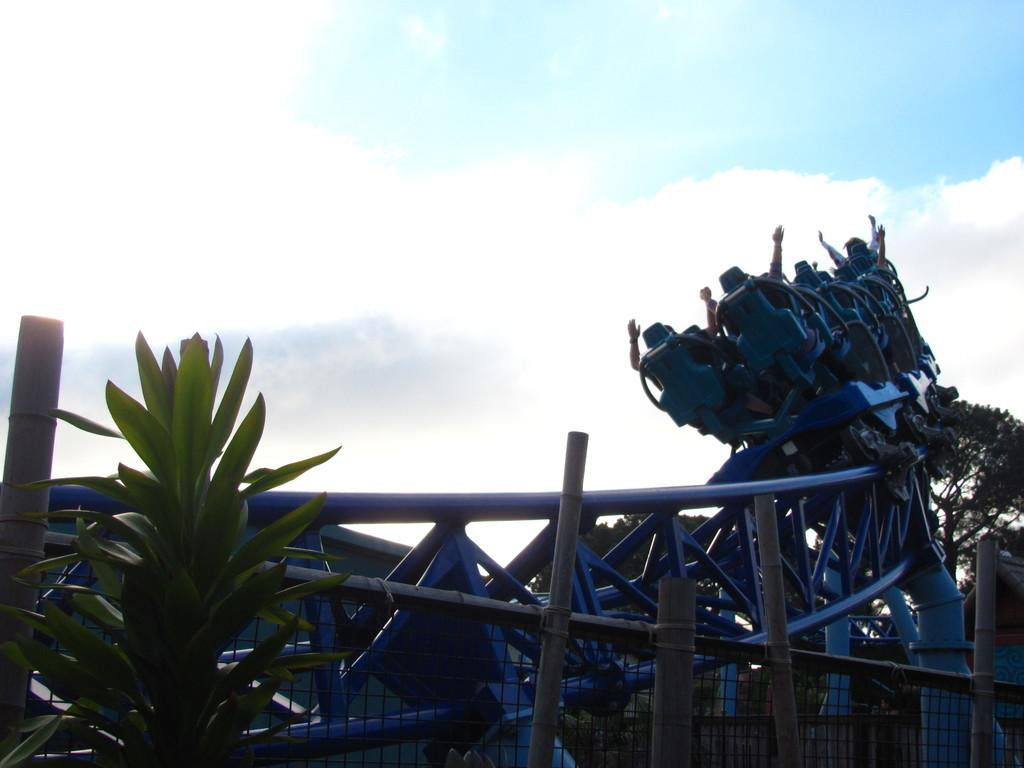What type of structure can be seen in the image? There is a fence in the image. What other natural elements are present in the image? There are plants and trees in the image. What activity are the people engaged in? The people are sitting on a roller coaster in the image. What can be seen in the background of the image? The sky is visible in the background of the image. What is the answer to the riddle written on the fence in the image? There is no riddle written on the fence in the image. How many engines are powering the roller coaster in the image? The image does not provide information about the number of engines powering the roller coaster. 